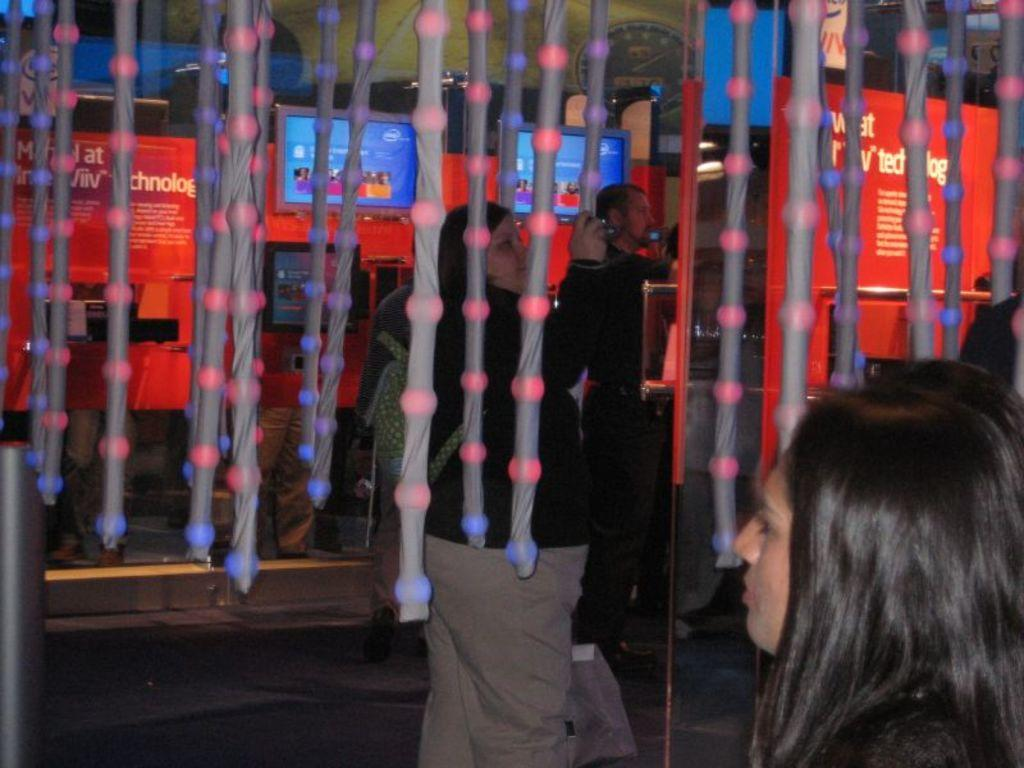What are the people in the image doing? The persons standing on the floor in the image are likely working or interacting with the machines. What can be seen in the background of the image? There are machines in the background of the image. What feature of the machines is visible in the image? The machines have displays visible in the image. How many spiders are crawling on the secretary's desk in the image? There are no spiders or desks present in the image. What type of trail can be seen in the image? There is no trail visible in the image. 